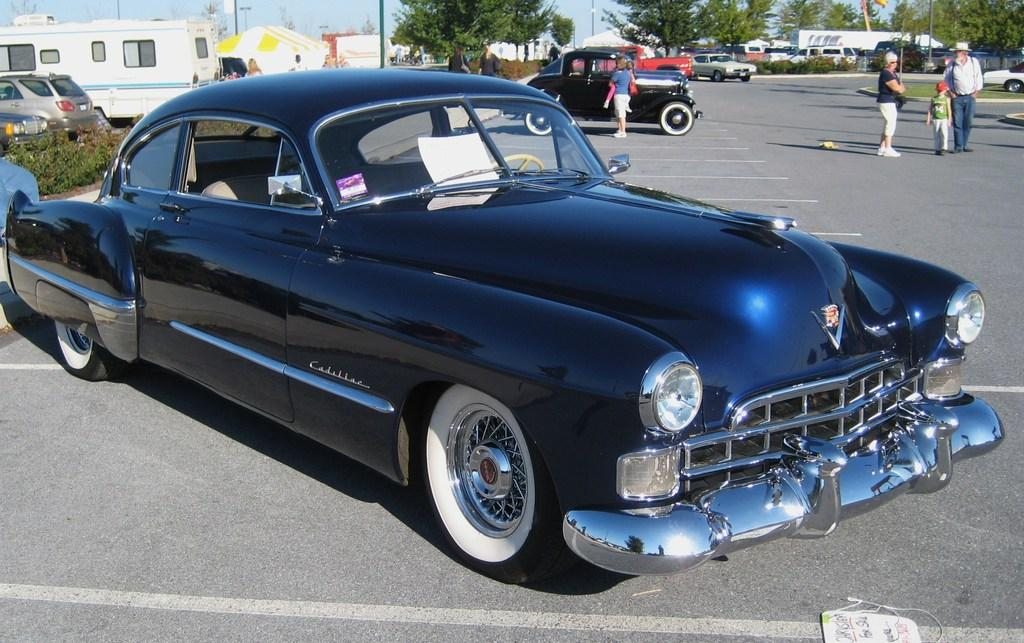What type of vehicle is in the front of the image? There is a black car in the front of the image. What can be seen in the background of the image? There are trees, persons, cars, poles, and tents in the background of the image. What is the ground made of in the image? There is grass on the ground in the image. What type of hen can be seen in the image? There is no hen present in the image. What season is depicted in the image based on the presence of tents and grass? The image does not provide enough information to determine the season. 